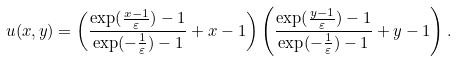<formula> <loc_0><loc_0><loc_500><loc_500>u ( x , y ) = \left ( \frac { \exp ( \frac { x - 1 } { \varepsilon } ) - 1 } { \exp ( - \frac { 1 } { \varepsilon } ) - 1 } + x - 1 \right ) \left ( \frac { \exp ( \frac { y - 1 } { \varepsilon } ) - 1 } { \exp ( - \frac { 1 } { \varepsilon } ) - 1 } + y - 1 \right ) .</formula> 